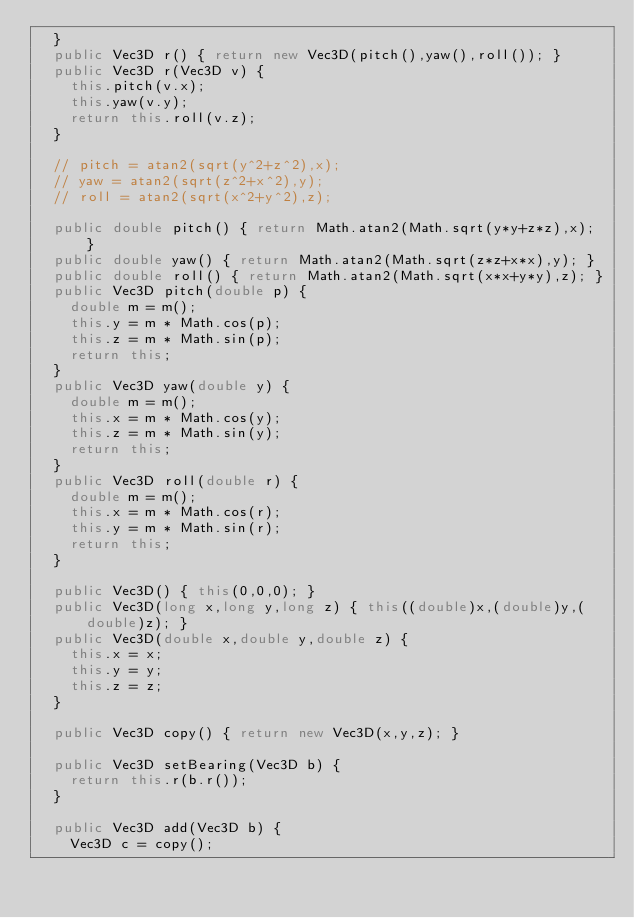Convert code to text. <code><loc_0><loc_0><loc_500><loc_500><_Java_>  }
  public Vec3D r() { return new Vec3D(pitch(),yaw(),roll()); }
  public Vec3D r(Vec3D v) {
    this.pitch(v.x);
    this.yaw(v.y);
    return this.roll(v.z);
  }

  // pitch = atan2(sqrt(y^2+z^2),x);
  // yaw = atan2(sqrt(z^2+x^2),y);
  // roll = atan2(sqrt(x^2+y^2),z);

  public double pitch() { return Math.atan2(Math.sqrt(y*y+z*z),x); }
  public double yaw() { return Math.atan2(Math.sqrt(z*z+x*x),y); }
  public double roll() { return Math.atan2(Math.sqrt(x*x+y*y),z); }
  public Vec3D pitch(double p) {
    double m = m();
    this.y = m * Math.cos(p);
    this.z = m * Math.sin(p);
    return this;
  }
  public Vec3D yaw(double y) {
    double m = m();
    this.x = m * Math.cos(y);
    this.z = m * Math.sin(y);
    return this;
  }
  public Vec3D roll(double r) {
    double m = m();
    this.x = m * Math.cos(r);
    this.y = m * Math.sin(r);
    return this;
  }

  public Vec3D() { this(0,0,0); }
  public Vec3D(long x,long y,long z) { this((double)x,(double)y,(double)z); }
  public Vec3D(double x,double y,double z) {
    this.x = x;
    this.y = y;
    this.z = z;
  }

  public Vec3D copy() { return new Vec3D(x,y,z); }

  public Vec3D setBearing(Vec3D b) {
    return this.r(b.r());
  }

  public Vec3D add(Vec3D b) {
    Vec3D c = copy();</code> 